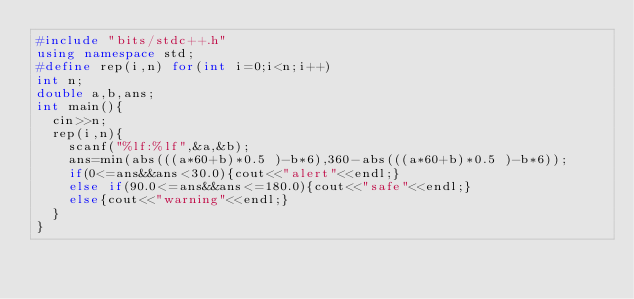<code> <loc_0><loc_0><loc_500><loc_500><_C++_>#include "bits/stdc++.h"
using namespace std;
#define rep(i,n) for(int i=0;i<n;i++)
int n;
double a,b,ans;
int main(){
	cin>>n;
	rep(i,n){
		scanf("%lf:%lf",&a,&b);
		ans=min(abs(((a*60+b)*0.5 )-b*6),360-abs(((a*60+b)*0.5 )-b*6));
		if(0<=ans&&ans<30.0){cout<<"alert"<<endl;}
		else if(90.0<=ans&&ans<=180.0){cout<<"safe"<<endl;}
		else{cout<<"warning"<<endl;}
	}
}</code> 